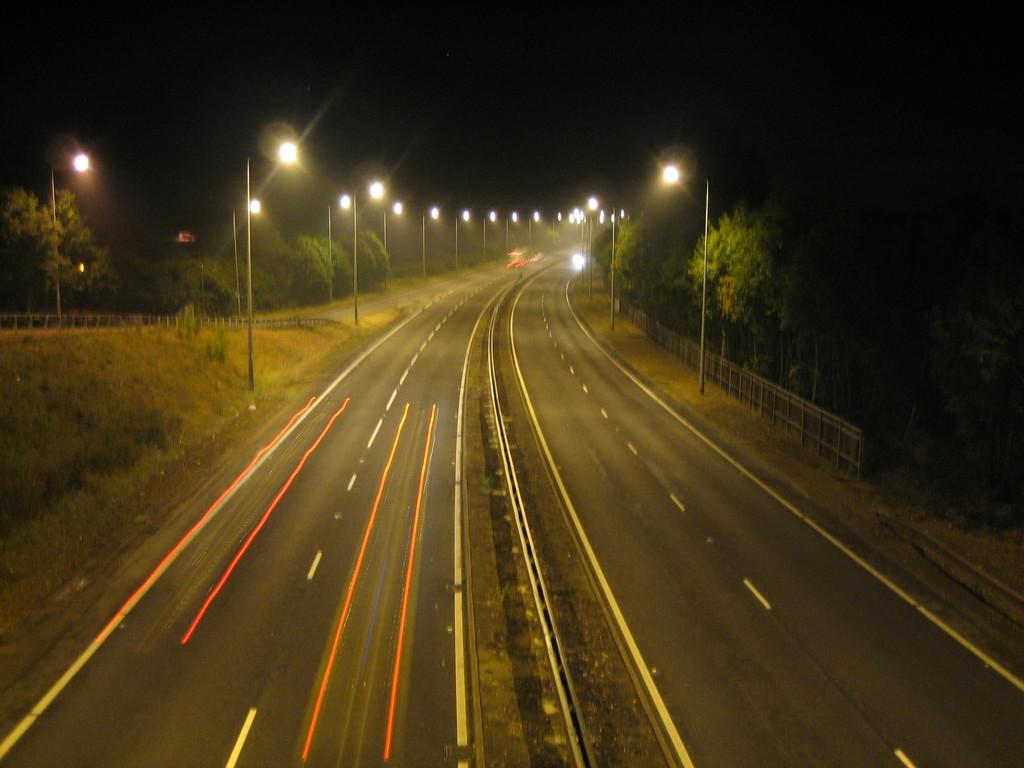What type of vegetation is on the left side of the image? There are trees on the left side of the image. What type of vegetation is on the right side of the image? There are trees on the right side of the image. What type of ground cover is present in the image? There is grass in the image. What type of lighting is present in the image? There are street lights in the image. What is in the middle of the image? There is a road in the middle of the image. What is the color of the background in the image? The background of the image is dark. Can you tell me how many nails the father is holding in the image? There is no father or nails present in the image. What type of horse can be seen grazing on the grass in the image? There is no horse present in the image; it features trees, grass, street lights, and a road. 